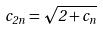<formula> <loc_0><loc_0><loc_500><loc_500>c _ { 2 n } = \sqrt { 2 + c _ { n } }</formula> 